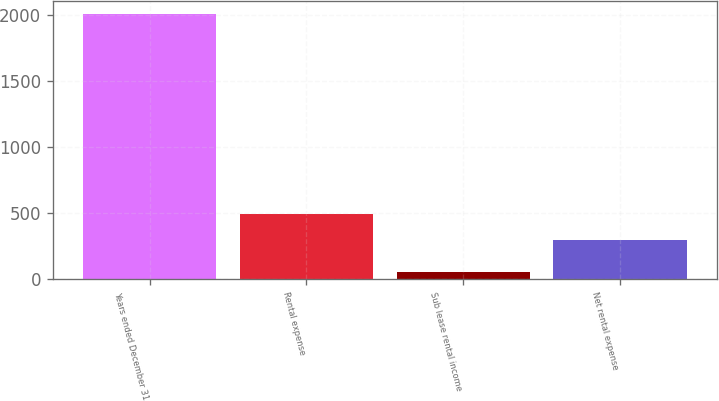<chart> <loc_0><loc_0><loc_500><loc_500><bar_chart><fcel>Years ended December 31<fcel>Rental expense<fcel>Sub lease rental income<fcel>Net rental expense<nl><fcel>2009<fcel>489.7<fcel>52<fcel>294<nl></chart> 